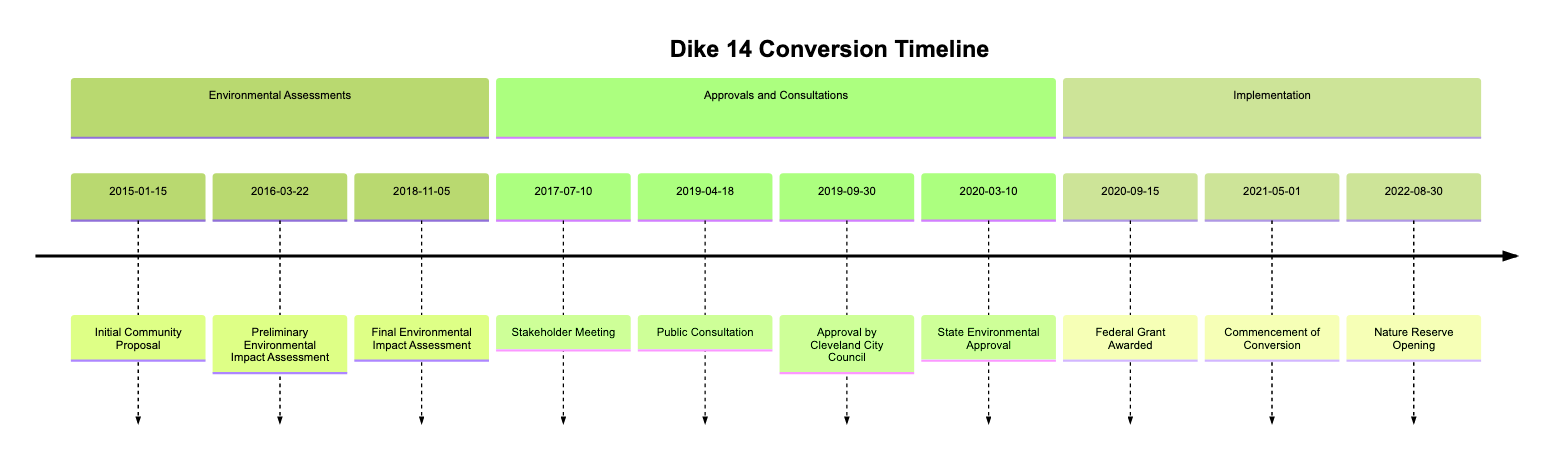What is the date of the Initial Community Proposal? The Initial Community Proposal is listed in the timeline with the date "2015-01-15".
Answer: 2015-01-15 Which event occurred after the Preliminary Environmental Impact Assessment? The event that follows the Preliminary Environmental Impact Assessment, which was completed on "2016-03-22", is the Stakeholder Meeting that took place on "2017-07-10".
Answer: Stakeholder Meeting How many environmental assessments are listed in the timeline? The diagram lists three environmental assessments: the Preliminary Environmental Impact Assessment, the Final Environmental Impact Assessment, and a Stakeholder Meeting, resulting in a total of three assessments combined.
Answer: 3 What event marks the official approval of the conversion by the Cleveland City Council? The official approval event from the Cleveland City Council is on "2019-09-30" in the timeline, which confirms the conversion of Dike 14.
Answer: Approval by Cleveland City Council Which event preceded the commencement of conversion? The event that directly preceded the Commencement of Conversion on "2021-05-01" is the Federal Grant Awarded on "2020-09-15". Chain the events: Federal Grant Awarded leads to Commencement of Conversion.
Answer: Federal Grant Awarded What is the last event listed in the timeline? The last event mentioned in the timeline for the Dike 14 conversion process is the Nature Reserve Opening on "2022-08-30".
Answer: Nature Reserve Opening In which section is the Final Environmental Impact Assessment found? The Final Environmental Impact Assessment is located in the Environmental Assessments section of the diagram timeline.
Answer: Environmental Assessments What year did the Public Consultation take place? The Public Consultation occurred on "2019-04-18", and thus the year is 2019.
Answer: 2019 What follows the Stakeholder Meeting in the timeline? Following the Stakeholder Meeting on "2017-07-10", the next event is the Final Environmental Impact Assessment on "2018-11-05".
Answer: Final Environmental Impact Assessment 